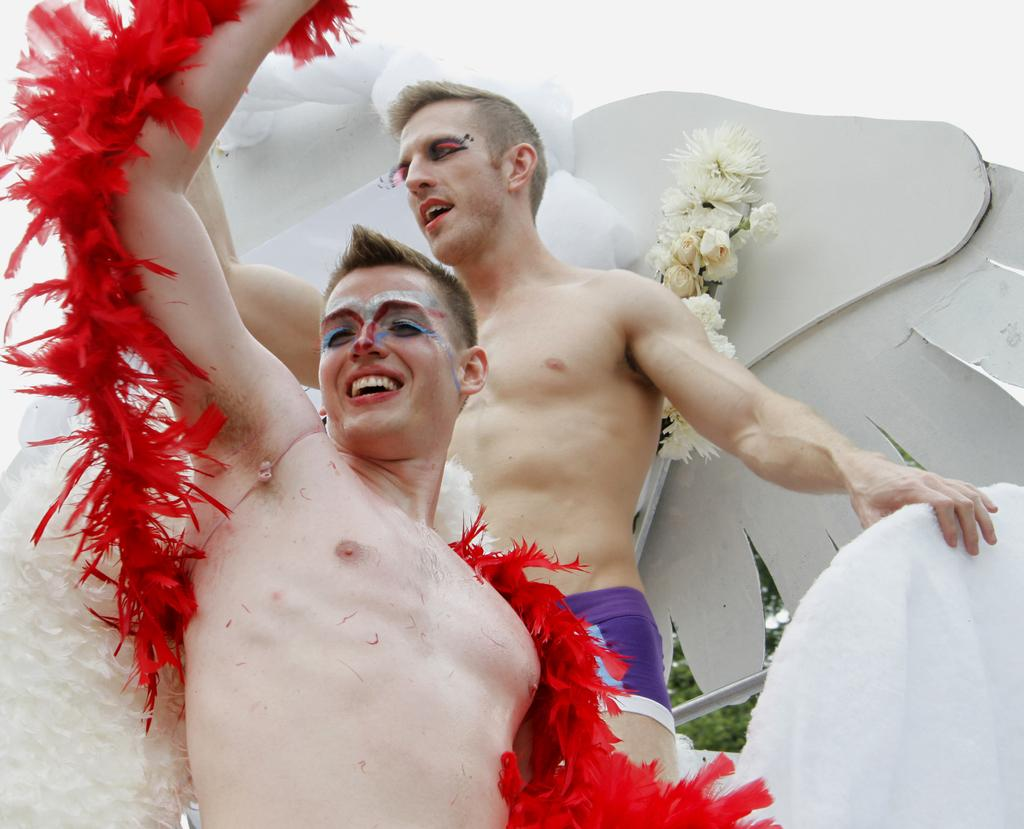How many people are in the image? There are two men in the image. What are the men doing in the image? The men are standing in the image. What is unique about the men's appearance? The men are wearing makeup in the image. What other objects can be seen in the image? There are feathers in the image. What is the color of the sky in the image? The sky is white in the image. How many pizzas can be seen in the image? There are no pizzas present in the image. Can you describe the eye makeup the men are wearing in the image? There is no specific mention of eye makeup in the provided facts, only that the men are wearing makeup in general. 